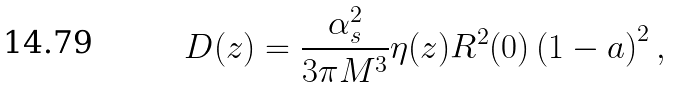Convert formula to latex. <formula><loc_0><loc_0><loc_500><loc_500>D ( z ) = \frac { \alpha ^ { 2 } _ { s } } { 3 \pi M ^ { 3 } } \eta ( z ) R ^ { 2 } ( 0 ) \left ( 1 - a \right ) ^ { 2 } ,</formula> 